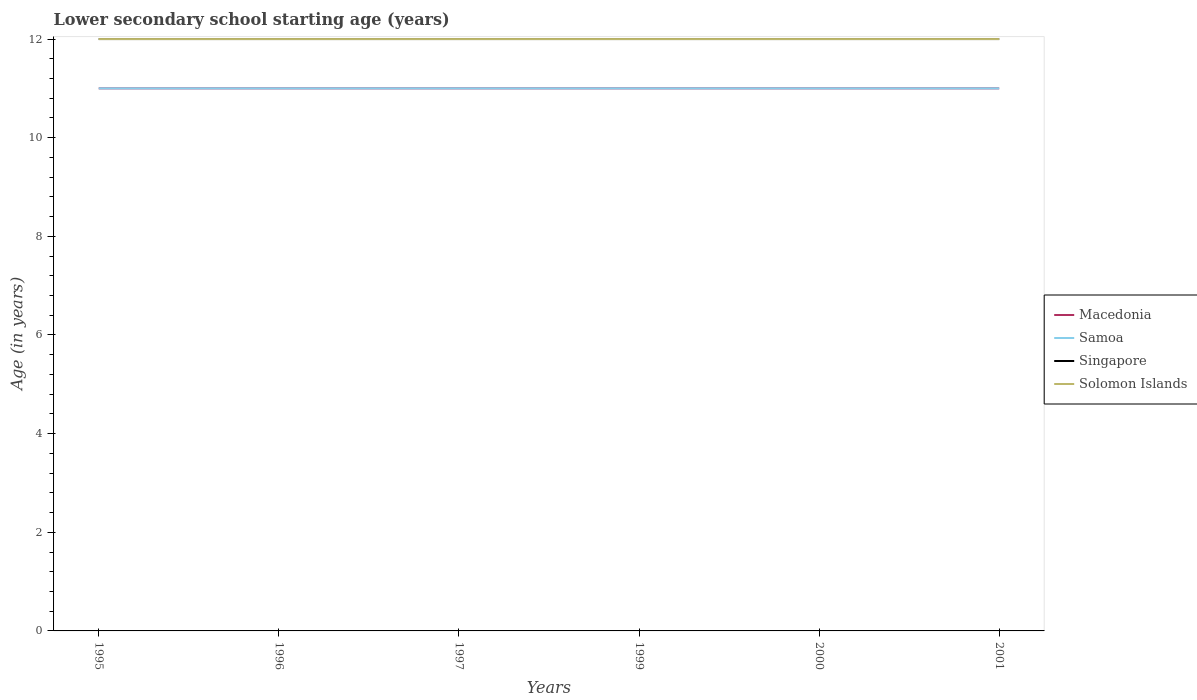Does the line corresponding to Singapore intersect with the line corresponding to Macedonia?
Make the answer very short. No. Is the number of lines equal to the number of legend labels?
Keep it short and to the point. Yes. Across all years, what is the maximum lower secondary school starting age of children in Solomon Islands?
Offer a terse response. 12. In which year was the lower secondary school starting age of children in Macedonia maximum?
Your answer should be compact. 1995. What is the total lower secondary school starting age of children in Singapore in the graph?
Offer a very short reply. 0. What is the difference between the highest and the second highest lower secondary school starting age of children in Samoa?
Offer a terse response. 0. Is the lower secondary school starting age of children in Solomon Islands strictly greater than the lower secondary school starting age of children in Macedonia over the years?
Provide a short and direct response. No. What is the difference between two consecutive major ticks on the Y-axis?
Your response must be concise. 2. Are the values on the major ticks of Y-axis written in scientific E-notation?
Keep it short and to the point. No. Does the graph contain any zero values?
Offer a terse response. No. Does the graph contain grids?
Offer a very short reply. No. Where does the legend appear in the graph?
Provide a short and direct response. Center right. How many legend labels are there?
Offer a terse response. 4. How are the legend labels stacked?
Your answer should be very brief. Vertical. What is the title of the graph?
Offer a very short reply. Lower secondary school starting age (years). Does "Other small states" appear as one of the legend labels in the graph?
Give a very brief answer. No. What is the label or title of the Y-axis?
Your response must be concise. Age (in years). What is the Age (in years) of Singapore in 1995?
Your response must be concise. 12. What is the Age (in years) of Solomon Islands in 1995?
Keep it short and to the point. 12. What is the Age (in years) in Macedonia in 1996?
Offer a terse response. 11. What is the Age (in years) in Samoa in 1997?
Your answer should be very brief. 11. What is the Age (in years) of Singapore in 1997?
Offer a very short reply. 12. What is the Age (in years) of Solomon Islands in 1997?
Your response must be concise. 12. What is the Age (in years) of Macedonia in 1999?
Offer a terse response. 11. What is the Age (in years) of Singapore in 1999?
Your response must be concise. 12. What is the Age (in years) in Solomon Islands in 1999?
Your answer should be compact. 12. What is the Age (in years) in Macedonia in 2000?
Provide a short and direct response. 11. What is the Age (in years) in Singapore in 2000?
Your answer should be very brief. 12. What is the Age (in years) of Solomon Islands in 2000?
Offer a very short reply. 12. What is the Age (in years) in Macedonia in 2001?
Your answer should be compact. 11. Across all years, what is the maximum Age (in years) of Macedonia?
Give a very brief answer. 11. Across all years, what is the maximum Age (in years) in Solomon Islands?
Your answer should be very brief. 12. What is the total Age (in years) in Singapore in the graph?
Ensure brevity in your answer.  72. What is the difference between the Age (in years) of Macedonia in 1995 and that in 1996?
Offer a terse response. 0. What is the difference between the Age (in years) in Macedonia in 1995 and that in 1997?
Provide a succinct answer. 0. What is the difference between the Age (in years) in Samoa in 1995 and that in 1997?
Offer a very short reply. 0. What is the difference between the Age (in years) of Solomon Islands in 1995 and that in 1997?
Your answer should be compact. 0. What is the difference between the Age (in years) of Samoa in 1995 and that in 1999?
Make the answer very short. 0. What is the difference between the Age (in years) in Singapore in 1995 and that in 1999?
Give a very brief answer. 0. What is the difference between the Age (in years) in Solomon Islands in 1995 and that in 1999?
Offer a very short reply. 0. What is the difference between the Age (in years) of Macedonia in 1995 and that in 2000?
Your answer should be very brief. 0. What is the difference between the Age (in years) in Samoa in 1995 and that in 2000?
Provide a short and direct response. 0. What is the difference between the Age (in years) of Samoa in 1995 and that in 2001?
Keep it short and to the point. 0. What is the difference between the Age (in years) of Singapore in 1995 and that in 2001?
Your answer should be compact. 0. What is the difference between the Age (in years) of Solomon Islands in 1995 and that in 2001?
Offer a very short reply. 0. What is the difference between the Age (in years) of Singapore in 1996 and that in 1997?
Offer a very short reply. 0. What is the difference between the Age (in years) of Macedonia in 1996 and that in 1999?
Your response must be concise. 0. What is the difference between the Age (in years) of Samoa in 1996 and that in 1999?
Your answer should be compact. 0. What is the difference between the Age (in years) of Singapore in 1996 and that in 1999?
Give a very brief answer. 0. What is the difference between the Age (in years) in Solomon Islands in 1996 and that in 1999?
Offer a very short reply. 0. What is the difference between the Age (in years) in Macedonia in 1996 and that in 2000?
Offer a very short reply. 0. What is the difference between the Age (in years) in Samoa in 1996 and that in 2000?
Provide a short and direct response. 0. What is the difference between the Age (in years) of Singapore in 1996 and that in 2001?
Your answer should be compact. 0. What is the difference between the Age (in years) in Macedonia in 1997 and that in 1999?
Your answer should be compact. 0. What is the difference between the Age (in years) in Samoa in 1997 and that in 1999?
Make the answer very short. 0. What is the difference between the Age (in years) of Singapore in 1997 and that in 1999?
Your answer should be compact. 0. What is the difference between the Age (in years) in Macedonia in 1997 and that in 2000?
Offer a terse response. 0. What is the difference between the Age (in years) in Samoa in 1997 and that in 2000?
Offer a terse response. 0. What is the difference between the Age (in years) in Singapore in 1997 and that in 2000?
Your response must be concise. 0. What is the difference between the Age (in years) of Macedonia in 1997 and that in 2001?
Ensure brevity in your answer.  0. What is the difference between the Age (in years) in Samoa in 1997 and that in 2001?
Ensure brevity in your answer.  0. What is the difference between the Age (in years) in Singapore in 1997 and that in 2001?
Give a very brief answer. 0. What is the difference between the Age (in years) in Solomon Islands in 1997 and that in 2001?
Provide a succinct answer. 0. What is the difference between the Age (in years) of Macedonia in 1999 and that in 2000?
Provide a short and direct response. 0. What is the difference between the Age (in years) in Samoa in 1999 and that in 2000?
Provide a succinct answer. 0. What is the difference between the Age (in years) of Singapore in 1999 and that in 2001?
Provide a succinct answer. 0. What is the difference between the Age (in years) in Macedonia in 2000 and that in 2001?
Offer a terse response. 0. What is the difference between the Age (in years) in Solomon Islands in 2000 and that in 2001?
Give a very brief answer. 0. What is the difference between the Age (in years) in Macedonia in 1995 and the Age (in years) in Singapore in 1996?
Your answer should be compact. -1. What is the difference between the Age (in years) of Macedonia in 1995 and the Age (in years) of Solomon Islands in 1996?
Offer a very short reply. -1. What is the difference between the Age (in years) of Samoa in 1995 and the Age (in years) of Singapore in 1996?
Ensure brevity in your answer.  -1. What is the difference between the Age (in years) in Samoa in 1995 and the Age (in years) in Solomon Islands in 1996?
Your answer should be very brief. -1. What is the difference between the Age (in years) of Singapore in 1995 and the Age (in years) of Solomon Islands in 1996?
Ensure brevity in your answer.  0. What is the difference between the Age (in years) of Macedonia in 1995 and the Age (in years) of Samoa in 1997?
Offer a very short reply. 0. What is the difference between the Age (in years) in Macedonia in 1995 and the Age (in years) in Singapore in 1997?
Give a very brief answer. -1. What is the difference between the Age (in years) of Samoa in 1995 and the Age (in years) of Singapore in 1997?
Offer a terse response. -1. What is the difference between the Age (in years) of Macedonia in 1995 and the Age (in years) of Singapore in 1999?
Offer a terse response. -1. What is the difference between the Age (in years) of Macedonia in 1995 and the Age (in years) of Solomon Islands in 1999?
Give a very brief answer. -1. What is the difference between the Age (in years) of Samoa in 1995 and the Age (in years) of Singapore in 1999?
Your response must be concise. -1. What is the difference between the Age (in years) of Macedonia in 1995 and the Age (in years) of Samoa in 2000?
Keep it short and to the point. 0. What is the difference between the Age (in years) in Macedonia in 1995 and the Age (in years) in Singapore in 2000?
Your answer should be very brief. -1. What is the difference between the Age (in years) of Macedonia in 1995 and the Age (in years) of Solomon Islands in 2000?
Offer a very short reply. -1. What is the difference between the Age (in years) in Samoa in 1995 and the Age (in years) in Solomon Islands in 2000?
Provide a short and direct response. -1. What is the difference between the Age (in years) in Samoa in 1995 and the Age (in years) in Singapore in 2001?
Ensure brevity in your answer.  -1. What is the difference between the Age (in years) of Samoa in 1995 and the Age (in years) of Solomon Islands in 2001?
Give a very brief answer. -1. What is the difference between the Age (in years) in Samoa in 1996 and the Age (in years) in Singapore in 1997?
Provide a succinct answer. -1. What is the difference between the Age (in years) of Singapore in 1996 and the Age (in years) of Solomon Islands in 1997?
Offer a very short reply. 0. What is the difference between the Age (in years) of Macedonia in 1996 and the Age (in years) of Solomon Islands in 1999?
Your answer should be compact. -1. What is the difference between the Age (in years) of Samoa in 1996 and the Age (in years) of Singapore in 1999?
Offer a very short reply. -1. What is the difference between the Age (in years) in Samoa in 1996 and the Age (in years) in Solomon Islands in 1999?
Provide a succinct answer. -1. What is the difference between the Age (in years) of Singapore in 1996 and the Age (in years) of Solomon Islands in 1999?
Give a very brief answer. 0. What is the difference between the Age (in years) in Macedonia in 1996 and the Age (in years) in Samoa in 2000?
Your response must be concise. 0. What is the difference between the Age (in years) in Macedonia in 1996 and the Age (in years) in Solomon Islands in 2000?
Your answer should be compact. -1. What is the difference between the Age (in years) of Samoa in 1996 and the Age (in years) of Singapore in 2001?
Provide a succinct answer. -1. What is the difference between the Age (in years) in Singapore in 1996 and the Age (in years) in Solomon Islands in 2001?
Give a very brief answer. 0. What is the difference between the Age (in years) in Macedonia in 1997 and the Age (in years) in Samoa in 1999?
Offer a terse response. 0. What is the difference between the Age (in years) in Macedonia in 1997 and the Age (in years) in Singapore in 1999?
Make the answer very short. -1. What is the difference between the Age (in years) in Macedonia in 1997 and the Age (in years) in Solomon Islands in 1999?
Provide a short and direct response. -1. What is the difference between the Age (in years) of Samoa in 1997 and the Age (in years) of Solomon Islands in 1999?
Your answer should be very brief. -1. What is the difference between the Age (in years) in Singapore in 1997 and the Age (in years) in Solomon Islands in 1999?
Provide a succinct answer. 0. What is the difference between the Age (in years) in Macedonia in 1997 and the Age (in years) in Samoa in 2000?
Your response must be concise. 0. What is the difference between the Age (in years) of Singapore in 1997 and the Age (in years) of Solomon Islands in 2000?
Make the answer very short. 0. What is the difference between the Age (in years) in Macedonia in 1997 and the Age (in years) in Singapore in 2001?
Provide a succinct answer. -1. What is the difference between the Age (in years) of Macedonia in 1997 and the Age (in years) of Solomon Islands in 2001?
Offer a terse response. -1. What is the difference between the Age (in years) in Samoa in 1997 and the Age (in years) in Singapore in 2001?
Offer a terse response. -1. What is the difference between the Age (in years) of Macedonia in 1999 and the Age (in years) of Samoa in 2000?
Offer a terse response. 0. What is the difference between the Age (in years) in Macedonia in 1999 and the Age (in years) in Solomon Islands in 2000?
Provide a succinct answer. -1. What is the difference between the Age (in years) in Samoa in 1999 and the Age (in years) in Solomon Islands in 2000?
Provide a short and direct response. -1. What is the difference between the Age (in years) of Macedonia in 1999 and the Age (in years) of Samoa in 2001?
Your answer should be very brief. 0. What is the difference between the Age (in years) in Macedonia in 1999 and the Age (in years) in Singapore in 2001?
Ensure brevity in your answer.  -1. What is the difference between the Age (in years) of Macedonia in 1999 and the Age (in years) of Solomon Islands in 2001?
Your response must be concise. -1. What is the difference between the Age (in years) of Samoa in 1999 and the Age (in years) of Singapore in 2001?
Give a very brief answer. -1. What is the difference between the Age (in years) of Macedonia in 2000 and the Age (in years) of Samoa in 2001?
Keep it short and to the point. 0. What is the difference between the Age (in years) of Macedonia in 2000 and the Age (in years) of Solomon Islands in 2001?
Offer a terse response. -1. What is the difference between the Age (in years) of Samoa in 2000 and the Age (in years) of Singapore in 2001?
Give a very brief answer. -1. What is the difference between the Age (in years) of Samoa in 2000 and the Age (in years) of Solomon Islands in 2001?
Offer a very short reply. -1. What is the difference between the Age (in years) in Singapore in 2000 and the Age (in years) in Solomon Islands in 2001?
Provide a short and direct response. 0. What is the average Age (in years) in Macedonia per year?
Your answer should be compact. 11. What is the average Age (in years) in Solomon Islands per year?
Ensure brevity in your answer.  12. In the year 1995, what is the difference between the Age (in years) of Macedonia and Age (in years) of Solomon Islands?
Your response must be concise. -1. In the year 1995, what is the difference between the Age (in years) of Samoa and Age (in years) of Singapore?
Provide a short and direct response. -1. In the year 1995, what is the difference between the Age (in years) of Samoa and Age (in years) of Solomon Islands?
Keep it short and to the point. -1. In the year 1995, what is the difference between the Age (in years) in Singapore and Age (in years) in Solomon Islands?
Your response must be concise. 0. In the year 1996, what is the difference between the Age (in years) in Macedonia and Age (in years) in Samoa?
Your answer should be very brief. 0. In the year 1996, what is the difference between the Age (in years) of Macedonia and Age (in years) of Singapore?
Your answer should be compact. -1. In the year 1996, what is the difference between the Age (in years) of Samoa and Age (in years) of Solomon Islands?
Give a very brief answer. -1. In the year 1996, what is the difference between the Age (in years) in Singapore and Age (in years) in Solomon Islands?
Offer a terse response. 0. In the year 1997, what is the difference between the Age (in years) in Macedonia and Age (in years) in Solomon Islands?
Your answer should be very brief. -1. In the year 1997, what is the difference between the Age (in years) in Samoa and Age (in years) in Singapore?
Provide a succinct answer. -1. In the year 1997, what is the difference between the Age (in years) of Singapore and Age (in years) of Solomon Islands?
Your response must be concise. 0. In the year 1999, what is the difference between the Age (in years) of Macedonia and Age (in years) of Samoa?
Keep it short and to the point. 0. In the year 1999, what is the difference between the Age (in years) in Macedonia and Age (in years) in Solomon Islands?
Offer a very short reply. -1. In the year 1999, what is the difference between the Age (in years) of Samoa and Age (in years) of Solomon Islands?
Provide a succinct answer. -1. In the year 2000, what is the difference between the Age (in years) of Singapore and Age (in years) of Solomon Islands?
Keep it short and to the point. 0. In the year 2001, what is the difference between the Age (in years) in Macedonia and Age (in years) in Solomon Islands?
Keep it short and to the point. -1. In the year 2001, what is the difference between the Age (in years) of Samoa and Age (in years) of Singapore?
Provide a short and direct response. -1. In the year 2001, what is the difference between the Age (in years) of Singapore and Age (in years) of Solomon Islands?
Your response must be concise. 0. What is the ratio of the Age (in years) in Samoa in 1995 to that in 1996?
Make the answer very short. 1. What is the ratio of the Age (in years) in Macedonia in 1995 to that in 1997?
Ensure brevity in your answer.  1. What is the ratio of the Age (in years) in Singapore in 1995 to that in 1997?
Give a very brief answer. 1. What is the ratio of the Age (in years) in Solomon Islands in 1995 to that in 1997?
Offer a terse response. 1. What is the ratio of the Age (in years) of Macedonia in 1995 to that in 1999?
Offer a very short reply. 1. What is the ratio of the Age (in years) in Samoa in 1995 to that in 1999?
Keep it short and to the point. 1. What is the ratio of the Age (in years) in Solomon Islands in 1995 to that in 1999?
Offer a very short reply. 1. What is the ratio of the Age (in years) of Macedonia in 1995 to that in 2000?
Your response must be concise. 1. What is the ratio of the Age (in years) of Singapore in 1995 to that in 2000?
Your answer should be very brief. 1. What is the ratio of the Age (in years) in Solomon Islands in 1995 to that in 2000?
Keep it short and to the point. 1. What is the ratio of the Age (in years) in Macedonia in 1995 to that in 2001?
Provide a short and direct response. 1. What is the ratio of the Age (in years) of Singapore in 1995 to that in 2001?
Make the answer very short. 1. What is the ratio of the Age (in years) in Solomon Islands in 1995 to that in 2001?
Ensure brevity in your answer.  1. What is the ratio of the Age (in years) in Macedonia in 1996 to that in 1997?
Provide a succinct answer. 1. What is the ratio of the Age (in years) in Singapore in 1996 to that in 1997?
Offer a very short reply. 1. What is the ratio of the Age (in years) in Solomon Islands in 1996 to that in 1997?
Your answer should be compact. 1. What is the ratio of the Age (in years) in Singapore in 1996 to that in 1999?
Offer a very short reply. 1. What is the ratio of the Age (in years) in Samoa in 1996 to that in 2000?
Make the answer very short. 1. What is the ratio of the Age (in years) of Singapore in 1996 to that in 2000?
Ensure brevity in your answer.  1. What is the ratio of the Age (in years) in Macedonia in 1996 to that in 2001?
Offer a very short reply. 1. What is the ratio of the Age (in years) of Samoa in 1996 to that in 2001?
Make the answer very short. 1. What is the ratio of the Age (in years) in Singapore in 1996 to that in 2001?
Provide a short and direct response. 1. What is the ratio of the Age (in years) in Samoa in 1997 to that in 1999?
Give a very brief answer. 1. What is the ratio of the Age (in years) in Solomon Islands in 1997 to that in 1999?
Offer a very short reply. 1. What is the ratio of the Age (in years) of Solomon Islands in 1997 to that in 2000?
Your response must be concise. 1. What is the ratio of the Age (in years) in Macedonia in 1997 to that in 2001?
Your response must be concise. 1. What is the ratio of the Age (in years) in Samoa in 1997 to that in 2001?
Provide a short and direct response. 1. What is the ratio of the Age (in years) of Solomon Islands in 1997 to that in 2001?
Provide a succinct answer. 1. What is the ratio of the Age (in years) of Samoa in 1999 to that in 2000?
Offer a terse response. 1. What is the ratio of the Age (in years) of Macedonia in 1999 to that in 2001?
Keep it short and to the point. 1. What is the ratio of the Age (in years) of Samoa in 2000 to that in 2001?
Your response must be concise. 1. What is the difference between the highest and the second highest Age (in years) of Macedonia?
Provide a short and direct response. 0. What is the difference between the highest and the lowest Age (in years) in Samoa?
Your answer should be compact. 0. What is the difference between the highest and the lowest Age (in years) in Solomon Islands?
Keep it short and to the point. 0. 